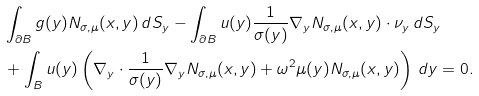<formula> <loc_0><loc_0><loc_500><loc_500>& \int _ { \partial B } g ( y ) N _ { \sigma , \mu } ( x , y ) \, d S _ { y } - \int _ { \partial B } u ( y ) \frac { 1 } { \sigma ( y ) } \nabla _ { y } N _ { \sigma , \mu } ( x , y ) \cdot \nu _ { y } \, d S _ { y } \\ & + \int _ { B } u ( y ) \left ( \nabla _ { y } \cdot \frac { 1 } { \sigma ( y ) } \nabla _ { y } N _ { \sigma , \mu } ( x , y ) + \omega ^ { 2 } \mu ( y ) N _ { \sigma , \mu } ( x , y ) \right ) \, d y = 0 .</formula> 